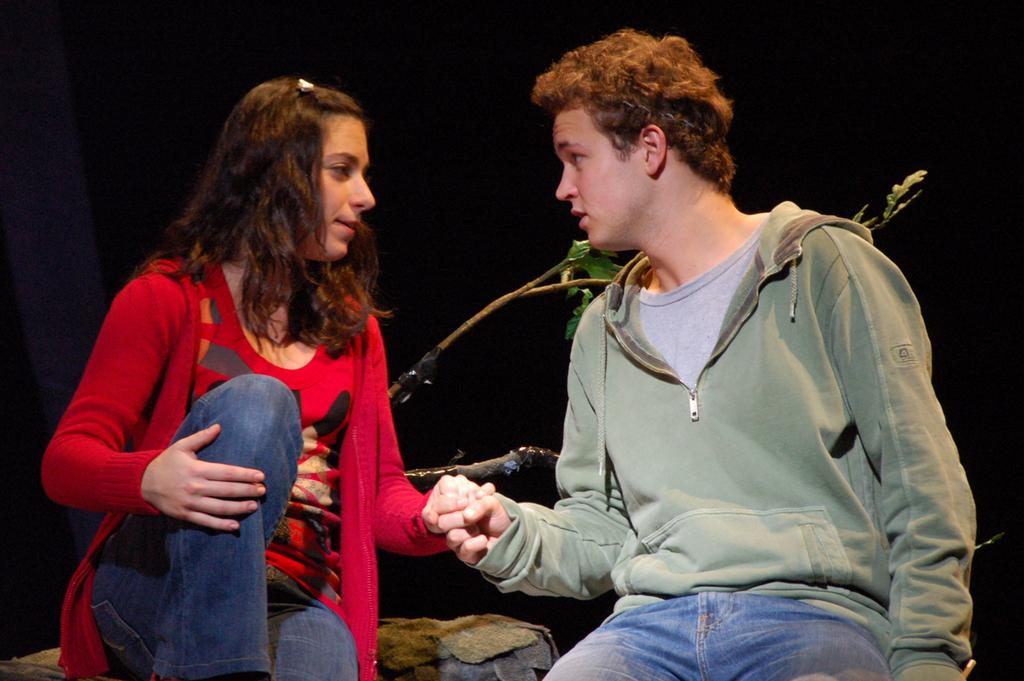Who is present in the image? There is a man and a woman in the image. What are the man and woman doing in the image? The man and woman are sitting and holding each other's hands. What other objects can be seen in the image? There is a rock and a plant in the image. How would you describe the background of the image? The background of the image appears dark. What type of pies are being served at the discovery event in the image? There is no mention of pies, discovery events, or tax in the image; it only features a man and a woman sitting and holding hands, along with a rock and a plant. 